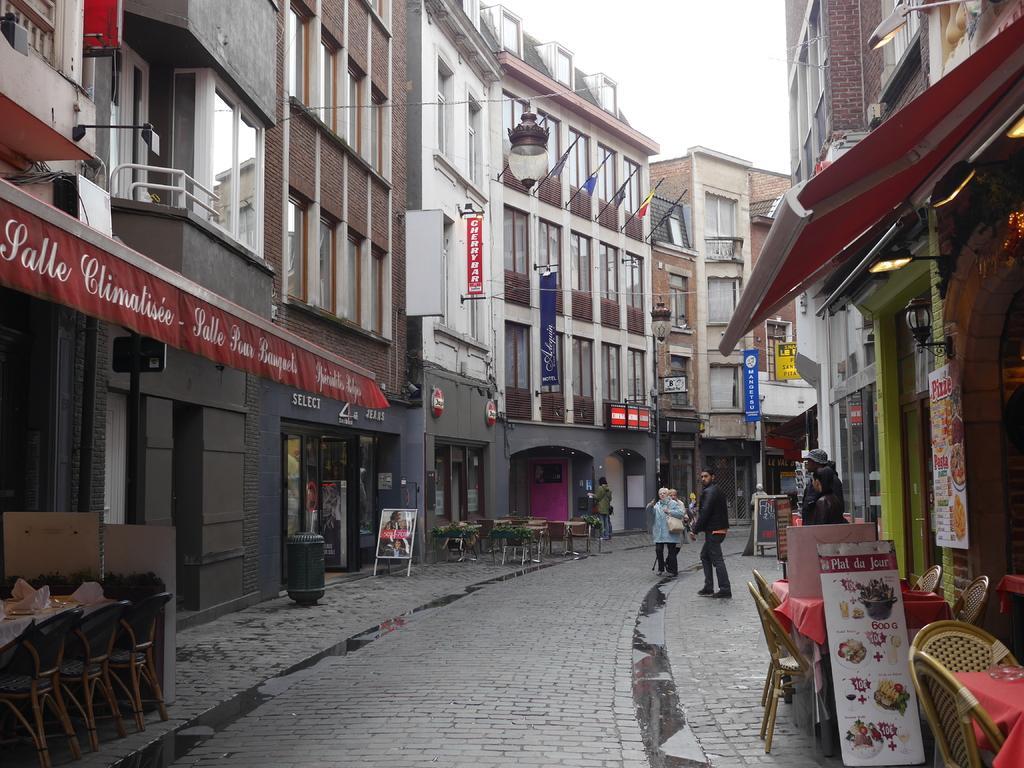In one or two sentences, can you explain what this image depicts? In the center of the image we can see persons walking on a road. On the left and right side we can see buildings. On the right side there are persons, tables, chairs. On the left side we can see chairs, table. In the background there is a sky. 